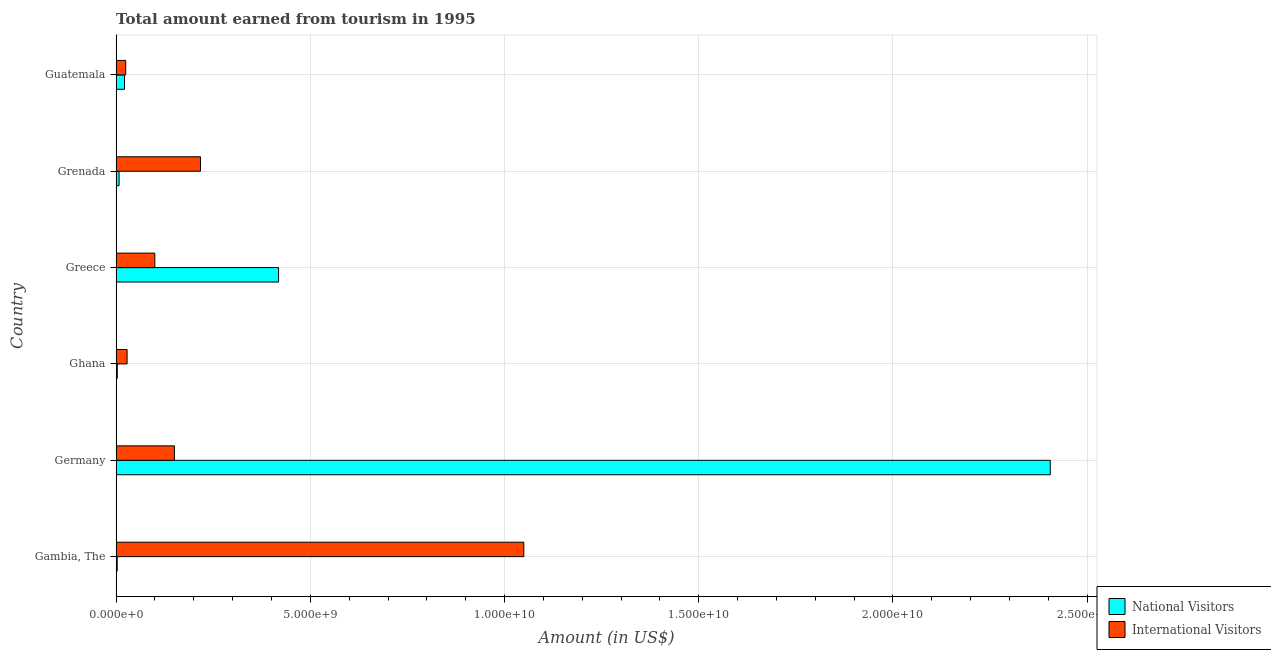Are the number of bars on each tick of the Y-axis equal?
Provide a short and direct response. Yes. How many bars are there on the 6th tick from the bottom?
Keep it short and to the point. 2. What is the label of the 1st group of bars from the top?
Make the answer very short. Guatemala. In how many cases, is the number of bars for a given country not equal to the number of legend labels?
Provide a succinct answer. 0. What is the amount earned from national visitors in Guatemala?
Give a very brief answer. 2.16e+08. Across all countries, what is the maximum amount earned from international visitors?
Provide a succinct answer. 1.05e+1. Across all countries, what is the minimum amount earned from national visitors?
Ensure brevity in your answer.  2.80e+07. In which country was the amount earned from national visitors maximum?
Give a very brief answer. Germany. In which country was the amount earned from national visitors minimum?
Offer a terse response. Gambia, The. What is the total amount earned from international visitors in the graph?
Your answer should be compact. 1.57e+1. What is the difference between the amount earned from national visitors in Gambia, The and that in Guatemala?
Offer a terse response. -1.88e+08. What is the difference between the amount earned from international visitors in Ghana and the amount earned from national visitors in Greece?
Make the answer very short. -3.90e+09. What is the average amount earned from international visitors per country?
Keep it short and to the point. 2.62e+09. What is the difference between the amount earned from international visitors and amount earned from national visitors in Guatemala?
Provide a succinct answer. 3.10e+07. In how many countries, is the amount earned from national visitors greater than 19000000000 US$?
Offer a very short reply. 1. What is the ratio of the amount earned from national visitors in Gambia, The to that in Greece?
Offer a terse response. 0.01. Is the amount earned from international visitors in Grenada less than that in Guatemala?
Your answer should be very brief. No. What is the difference between the highest and the second highest amount earned from international visitors?
Offer a terse response. 8.32e+09. What is the difference between the highest and the lowest amount earned from international visitors?
Offer a terse response. 1.02e+1. Is the sum of the amount earned from international visitors in Greece and Guatemala greater than the maximum amount earned from national visitors across all countries?
Your answer should be very brief. No. What does the 2nd bar from the top in Gambia, The represents?
Give a very brief answer. National Visitors. What does the 1st bar from the bottom in Germany represents?
Your answer should be compact. National Visitors. How many bars are there?
Provide a short and direct response. 12. How many countries are there in the graph?
Give a very brief answer. 6. What is the difference between two consecutive major ticks on the X-axis?
Keep it short and to the point. 5.00e+09. Are the values on the major ticks of X-axis written in scientific E-notation?
Your answer should be compact. Yes. Does the graph contain any zero values?
Your answer should be compact. No. Does the graph contain grids?
Keep it short and to the point. Yes. Where does the legend appear in the graph?
Make the answer very short. Bottom right. What is the title of the graph?
Your answer should be compact. Total amount earned from tourism in 1995. Does "Infant" appear as one of the legend labels in the graph?
Provide a short and direct response. No. What is the label or title of the X-axis?
Your answer should be compact. Amount (in US$). What is the Amount (in US$) in National Visitors in Gambia, The?
Keep it short and to the point. 2.80e+07. What is the Amount (in US$) of International Visitors in Gambia, The?
Your response must be concise. 1.05e+1. What is the Amount (in US$) of National Visitors in Germany?
Your answer should be compact. 2.41e+1. What is the Amount (in US$) of International Visitors in Germany?
Offer a terse response. 1.50e+09. What is the Amount (in US$) in National Visitors in Ghana?
Provide a short and direct response. 3.00e+07. What is the Amount (in US$) of International Visitors in Ghana?
Offer a very short reply. 2.82e+08. What is the Amount (in US$) of National Visitors in Greece?
Your answer should be compact. 4.18e+09. What is the Amount (in US$) in International Visitors in Greece?
Ensure brevity in your answer.  9.96e+08. What is the Amount (in US$) in National Visitors in Grenada?
Make the answer very short. 7.60e+07. What is the Amount (in US$) in International Visitors in Grenada?
Provide a short and direct response. 2.17e+09. What is the Amount (in US$) in National Visitors in Guatemala?
Offer a very short reply. 2.16e+08. What is the Amount (in US$) of International Visitors in Guatemala?
Provide a short and direct response. 2.47e+08. Across all countries, what is the maximum Amount (in US$) of National Visitors?
Your answer should be compact. 2.41e+1. Across all countries, what is the maximum Amount (in US$) in International Visitors?
Your response must be concise. 1.05e+1. Across all countries, what is the minimum Amount (in US$) of National Visitors?
Keep it short and to the point. 2.80e+07. Across all countries, what is the minimum Amount (in US$) in International Visitors?
Provide a short and direct response. 2.47e+08. What is the total Amount (in US$) of National Visitors in the graph?
Your answer should be compact. 2.86e+1. What is the total Amount (in US$) in International Visitors in the graph?
Keep it short and to the point. 1.57e+1. What is the difference between the Amount (in US$) in National Visitors in Gambia, The and that in Germany?
Provide a succinct answer. -2.40e+1. What is the difference between the Amount (in US$) in International Visitors in Gambia, The and that in Germany?
Your answer should be very brief. 9.00e+09. What is the difference between the Amount (in US$) in National Visitors in Gambia, The and that in Ghana?
Give a very brief answer. -2.00e+06. What is the difference between the Amount (in US$) of International Visitors in Gambia, The and that in Ghana?
Provide a succinct answer. 1.02e+1. What is the difference between the Amount (in US$) in National Visitors in Gambia, The and that in Greece?
Provide a short and direct response. -4.15e+09. What is the difference between the Amount (in US$) in International Visitors in Gambia, The and that in Greece?
Your answer should be compact. 9.50e+09. What is the difference between the Amount (in US$) of National Visitors in Gambia, The and that in Grenada?
Ensure brevity in your answer.  -4.80e+07. What is the difference between the Amount (in US$) of International Visitors in Gambia, The and that in Grenada?
Ensure brevity in your answer.  8.32e+09. What is the difference between the Amount (in US$) in National Visitors in Gambia, The and that in Guatemala?
Your answer should be very brief. -1.88e+08. What is the difference between the Amount (in US$) in International Visitors in Gambia, The and that in Guatemala?
Keep it short and to the point. 1.02e+1. What is the difference between the Amount (in US$) of National Visitors in Germany and that in Ghana?
Provide a short and direct response. 2.40e+1. What is the difference between the Amount (in US$) of International Visitors in Germany and that in Ghana?
Your response must be concise. 1.22e+09. What is the difference between the Amount (in US$) of National Visitors in Germany and that in Greece?
Ensure brevity in your answer.  1.99e+1. What is the difference between the Amount (in US$) in International Visitors in Germany and that in Greece?
Offer a terse response. 5.05e+08. What is the difference between the Amount (in US$) of National Visitors in Germany and that in Grenada?
Your answer should be compact. 2.40e+1. What is the difference between the Amount (in US$) in International Visitors in Germany and that in Grenada?
Keep it short and to the point. -6.71e+08. What is the difference between the Amount (in US$) of National Visitors in Germany and that in Guatemala?
Ensure brevity in your answer.  2.38e+1. What is the difference between the Amount (in US$) of International Visitors in Germany and that in Guatemala?
Give a very brief answer. 1.25e+09. What is the difference between the Amount (in US$) in National Visitors in Ghana and that in Greece?
Your answer should be very brief. -4.15e+09. What is the difference between the Amount (in US$) in International Visitors in Ghana and that in Greece?
Give a very brief answer. -7.14e+08. What is the difference between the Amount (in US$) of National Visitors in Ghana and that in Grenada?
Keep it short and to the point. -4.60e+07. What is the difference between the Amount (in US$) of International Visitors in Ghana and that in Grenada?
Give a very brief answer. -1.89e+09. What is the difference between the Amount (in US$) in National Visitors in Ghana and that in Guatemala?
Keep it short and to the point. -1.86e+08. What is the difference between the Amount (in US$) in International Visitors in Ghana and that in Guatemala?
Offer a terse response. 3.50e+07. What is the difference between the Amount (in US$) in National Visitors in Greece and that in Grenada?
Give a very brief answer. 4.11e+09. What is the difference between the Amount (in US$) of International Visitors in Greece and that in Grenada?
Offer a terse response. -1.18e+09. What is the difference between the Amount (in US$) of National Visitors in Greece and that in Guatemala?
Your answer should be very brief. 3.97e+09. What is the difference between the Amount (in US$) of International Visitors in Greece and that in Guatemala?
Ensure brevity in your answer.  7.49e+08. What is the difference between the Amount (in US$) of National Visitors in Grenada and that in Guatemala?
Your answer should be compact. -1.40e+08. What is the difference between the Amount (in US$) of International Visitors in Grenada and that in Guatemala?
Give a very brief answer. 1.92e+09. What is the difference between the Amount (in US$) in National Visitors in Gambia, The and the Amount (in US$) in International Visitors in Germany?
Your answer should be compact. -1.47e+09. What is the difference between the Amount (in US$) in National Visitors in Gambia, The and the Amount (in US$) in International Visitors in Ghana?
Offer a terse response. -2.54e+08. What is the difference between the Amount (in US$) in National Visitors in Gambia, The and the Amount (in US$) in International Visitors in Greece?
Offer a very short reply. -9.68e+08. What is the difference between the Amount (in US$) of National Visitors in Gambia, The and the Amount (in US$) of International Visitors in Grenada?
Give a very brief answer. -2.14e+09. What is the difference between the Amount (in US$) in National Visitors in Gambia, The and the Amount (in US$) in International Visitors in Guatemala?
Ensure brevity in your answer.  -2.19e+08. What is the difference between the Amount (in US$) in National Visitors in Germany and the Amount (in US$) in International Visitors in Ghana?
Offer a terse response. 2.38e+1. What is the difference between the Amount (in US$) in National Visitors in Germany and the Amount (in US$) in International Visitors in Greece?
Provide a short and direct response. 2.31e+1. What is the difference between the Amount (in US$) of National Visitors in Germany and the Amount (in US$) of International Visitors in Grenada?
Provide a succinct answer. 2.19e+1. What is the difference between the Amount (in US$) of National Visitors in Germany and the Amount (in US$) of International Visitors in Guatemala?
Your answer should be compact. 2.38e+1. What is the difference between the Amount (in US$) in National Visitors in Ghana and the Amount (in US$) in International Visitors in Greece?
Your answer should be very brief. -9.66e+08. What is the difference between the Amount (in US$) in National Visitors in Ghana and the Amount (in US$) in International Visitors in Grenada?
Provide a succinct answer. -2.14e+09. What is the difference between the Amount (in US$) of National Visitors in Ghana and the Amount (in US$) of International Visitors in Guatemala?
Your response must be concise. -2.17e+08. What is the difference between the Amount (in US$) in National Visitors in Greece and the Amount (in US$) in International Visitors in Grenada?
Your answer should be very brief. 2.01e+09. What is the difference between the Amount (in US$) in National Visitors in Greece and the Amount (in US$) in International Visitors in Guatemala?
Your response must be concise. 3.94e+09. What is the difference between the Amount (in US$) of National Visitors in Grenada and the Amount (in US$) of International Visitors in Guatemala?
Offer a very short reply. -1.71e+08. What is the average Amount (in US$) in National Visitors per country?
Your response must be concise. 4.76e+09. What is the average Amount (in US$) in International Visitors per country?
Offer a very short reply. 2.62e+09. What is the difference between the Amount (in US$) in National Visitors and Amount (in US$) in International Visitors in Gambia, The?
Offer a terse response. -1.05e+1. What is the difference between the Amount (in US$) in National Visitors and Amount (in US$) in International Visitors in Germany?
Ensure brevity in your answer.  2.26e+1. What is the difference between the Amount (in US$) of National Visitors and Amount (in US$) of International Visitors in Ghana?
Ensure brevity in your answer.  -2.52e+08. What is the difference between the Amount (in US$) of National Visitors and Amount (in US$) of International Visitors in Greece?
Provide a short and direct response. 3.19e+09. What is the difference between the Amount (in US$) in National Visitors and Amount (in US$) in International Visitors in Grenada?
Give a very brief answer. -2.10e+09. What is the difference between the Amount (in US$) in National Visitors and Amount (in US$) in International Visitors in Guatemala?
Ensure brevity in your answer.  -3.10e+07. What is the ratio of the Amount (in US$) of National Visitors in Gambia, The to that in Germany?
Your response must be concise. 0. What is the ratio of the Amount (in US$) in International Visitors in Gambia, The to that in Germany?
Offer a terse response. 6.99. What is the ratio of the Amount (in US$) of International Visitors in Gambia, The to that in Ghana?
Ensure brevity in your answer.  37.22. What is the ratio of the Amount (in US$) in National Visitors in Gambia, The to that in Greece?
Your answer should be very brief. 0.01. What is the ratio of the Amount (in US$) in International Visitors in Gambia, The to that in Greece?
Offer a terse response. 10.54. What is the ratio of the Amount (in US$) in National Visitors in Gambia, The to that in Grenada?
Provide a short and direct response. 0.37. What is the ratio of the Amount (in US$) of International Visitors in Gambia, The to that in Grenada?
Offer a very short reply. 4.83. What is the ratio of the Amount (in US$) in National Visitors in Gambia, The to that in Guatemala?
Offer a terse response. 0.13. What is the ratio of the Amount (in US$) of International Visitors in Gambia, The to that in Guatemala?
Provide a short and direct response. 42.5. What is the ratio of the Amount (in US$) of National Visitors in Germany to that in Ghana?
Ensure brevity in your answer.  801.73. What is the ratio of the Amount (in US$) in International Visitors in Germany to that in Ghana?
Your answer should be very brief. 5.32. What is the ratio of the Amount (in US$) of National Visitors in Germany to that in Greece?
Your response must be concise. 5.75. What is the ratio of the Amount (in US$) of International Visitors in Germany to that in Greece?
Make the answer very short. 1.51. What is the ratio of the Amount (in US$) of National Visitors in Germany to that in Grenada?
Provide a short and direct response. 316.47. What is the ratio of the Amount (in US$) in International Visitors in Germany to that in Grenada?
Give a very brief answer. 0.69. What is the ratio of the Amount (in US$) of National Visitors in Germany to that in Guatemala?
Keep it short and to the point. 111.35. What is the ratio of the Amount (in US$) of International Visitors in Germany to that in Guatemala?
Ensure brevity in your answer.  6.08. What is the ratio of the Amount (in US$) of National Visitors in Ghana to that in Greece?
Keep it short and to the point. 0.01. What is the ratio of the Amount (in US$) of International Visitors in Ghana to that in Greece?
Make the answer very short. 0.28. What is the ratio of the Amount (in US$) of National Visitors in Ghana to that in Grenada?
Offer a terse response. 0.39. What is the ratio of the Amount (in US$) in International Visitors in Ghana to that in Grenada?
Your answer should be very brief. 0.13. What is the ratio of the Amount (in US$) in National Visitors in Ghana to that in Guatemala?
Keep it short and to the point. 0.14. What is the ratio of the Amount (in US$) in International Visitors in Ghana to that in Guatemala?
Provide a short and direct response. 1.14. What is the ratio of the Amount (in US$) in National Visitors in Greece to that in Grenada?
Your response must be concise. 55.03. What is the ratio of the Amount (in US$) of International Visitors in Greece to that in Grenada?
Your answer should be very brief. 0.46. What is the ratio of the Amount (in US$) in National Visitors in Greece to that in Guatemala?
Make the answer very short. 19.36. What is the ratio of the Amount (in US$) of International Visitors in Greece to that in Guatemala?
Offer a terse response. 4.03. What is the ratio of the Amount (in US$) of National Visitors in Grenada to that in Guatemala?
Your response must be concise. 0.35. What is the ratio of the Amount (in US$) of International Visitors in Grenada to that in Guatemala?
Keep it short and to the point. 8.79. What is the difference between the highest and the second highest Amount (in US$) in National Visitors?
Make the answer very short. 1.99e+1. What is the difference between the highest and the second highest Amount (in US$) of International Visitors?
Offer a very short reply. 8.32e+09. What is the difference between the highest and the lowest Amount (in US$) in National Visitors?
Provide a succinct answer. 2.40e+1. What is the difference between the highest and the lowest Amount (in US$) in International Visitors?
Keep it short and to the point. 1.02e+1. 